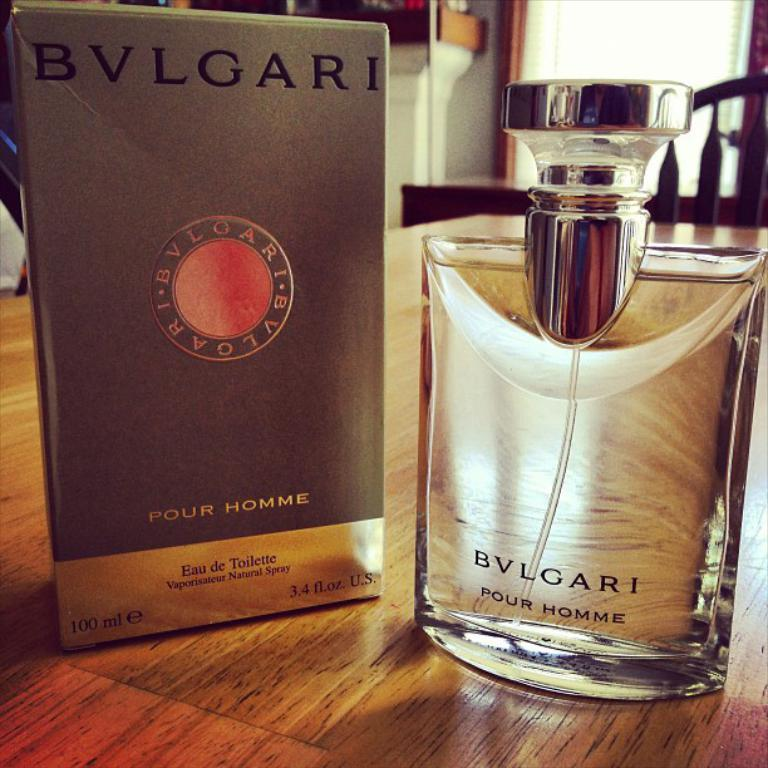<image>
Share a concise interpretation of the image provided. a box with an item in it that says four homme 